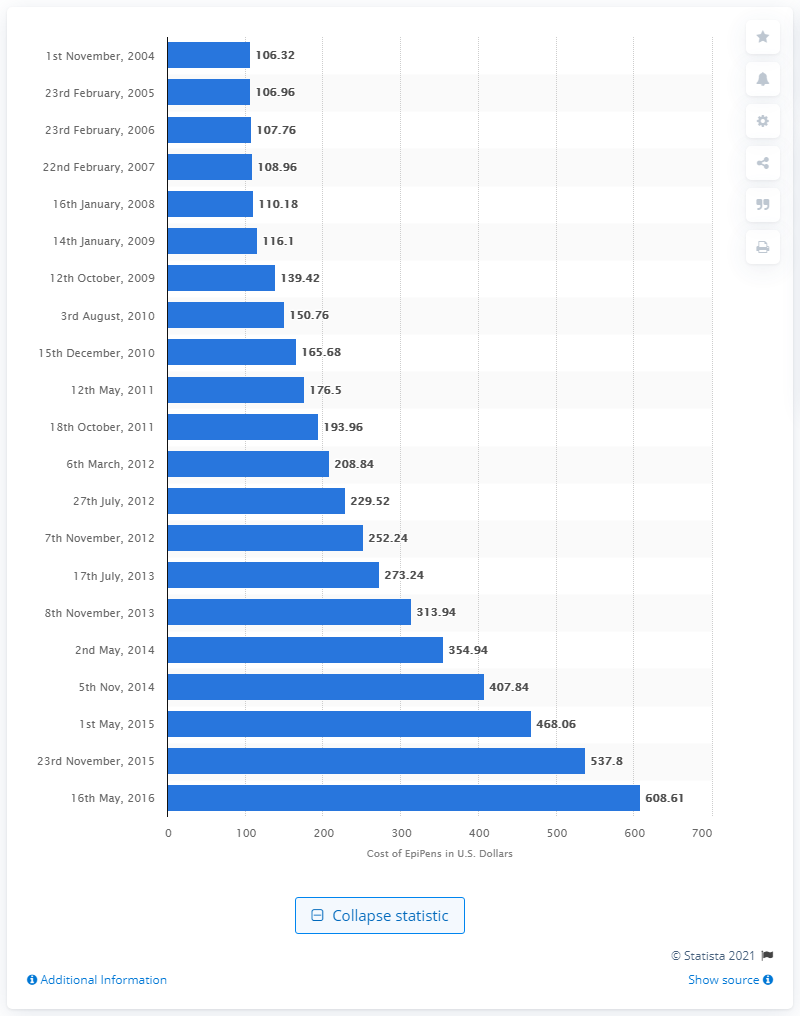Identify some key points in this picture. In May 2016, the cost of EpiPens was 608.61 dollars. 